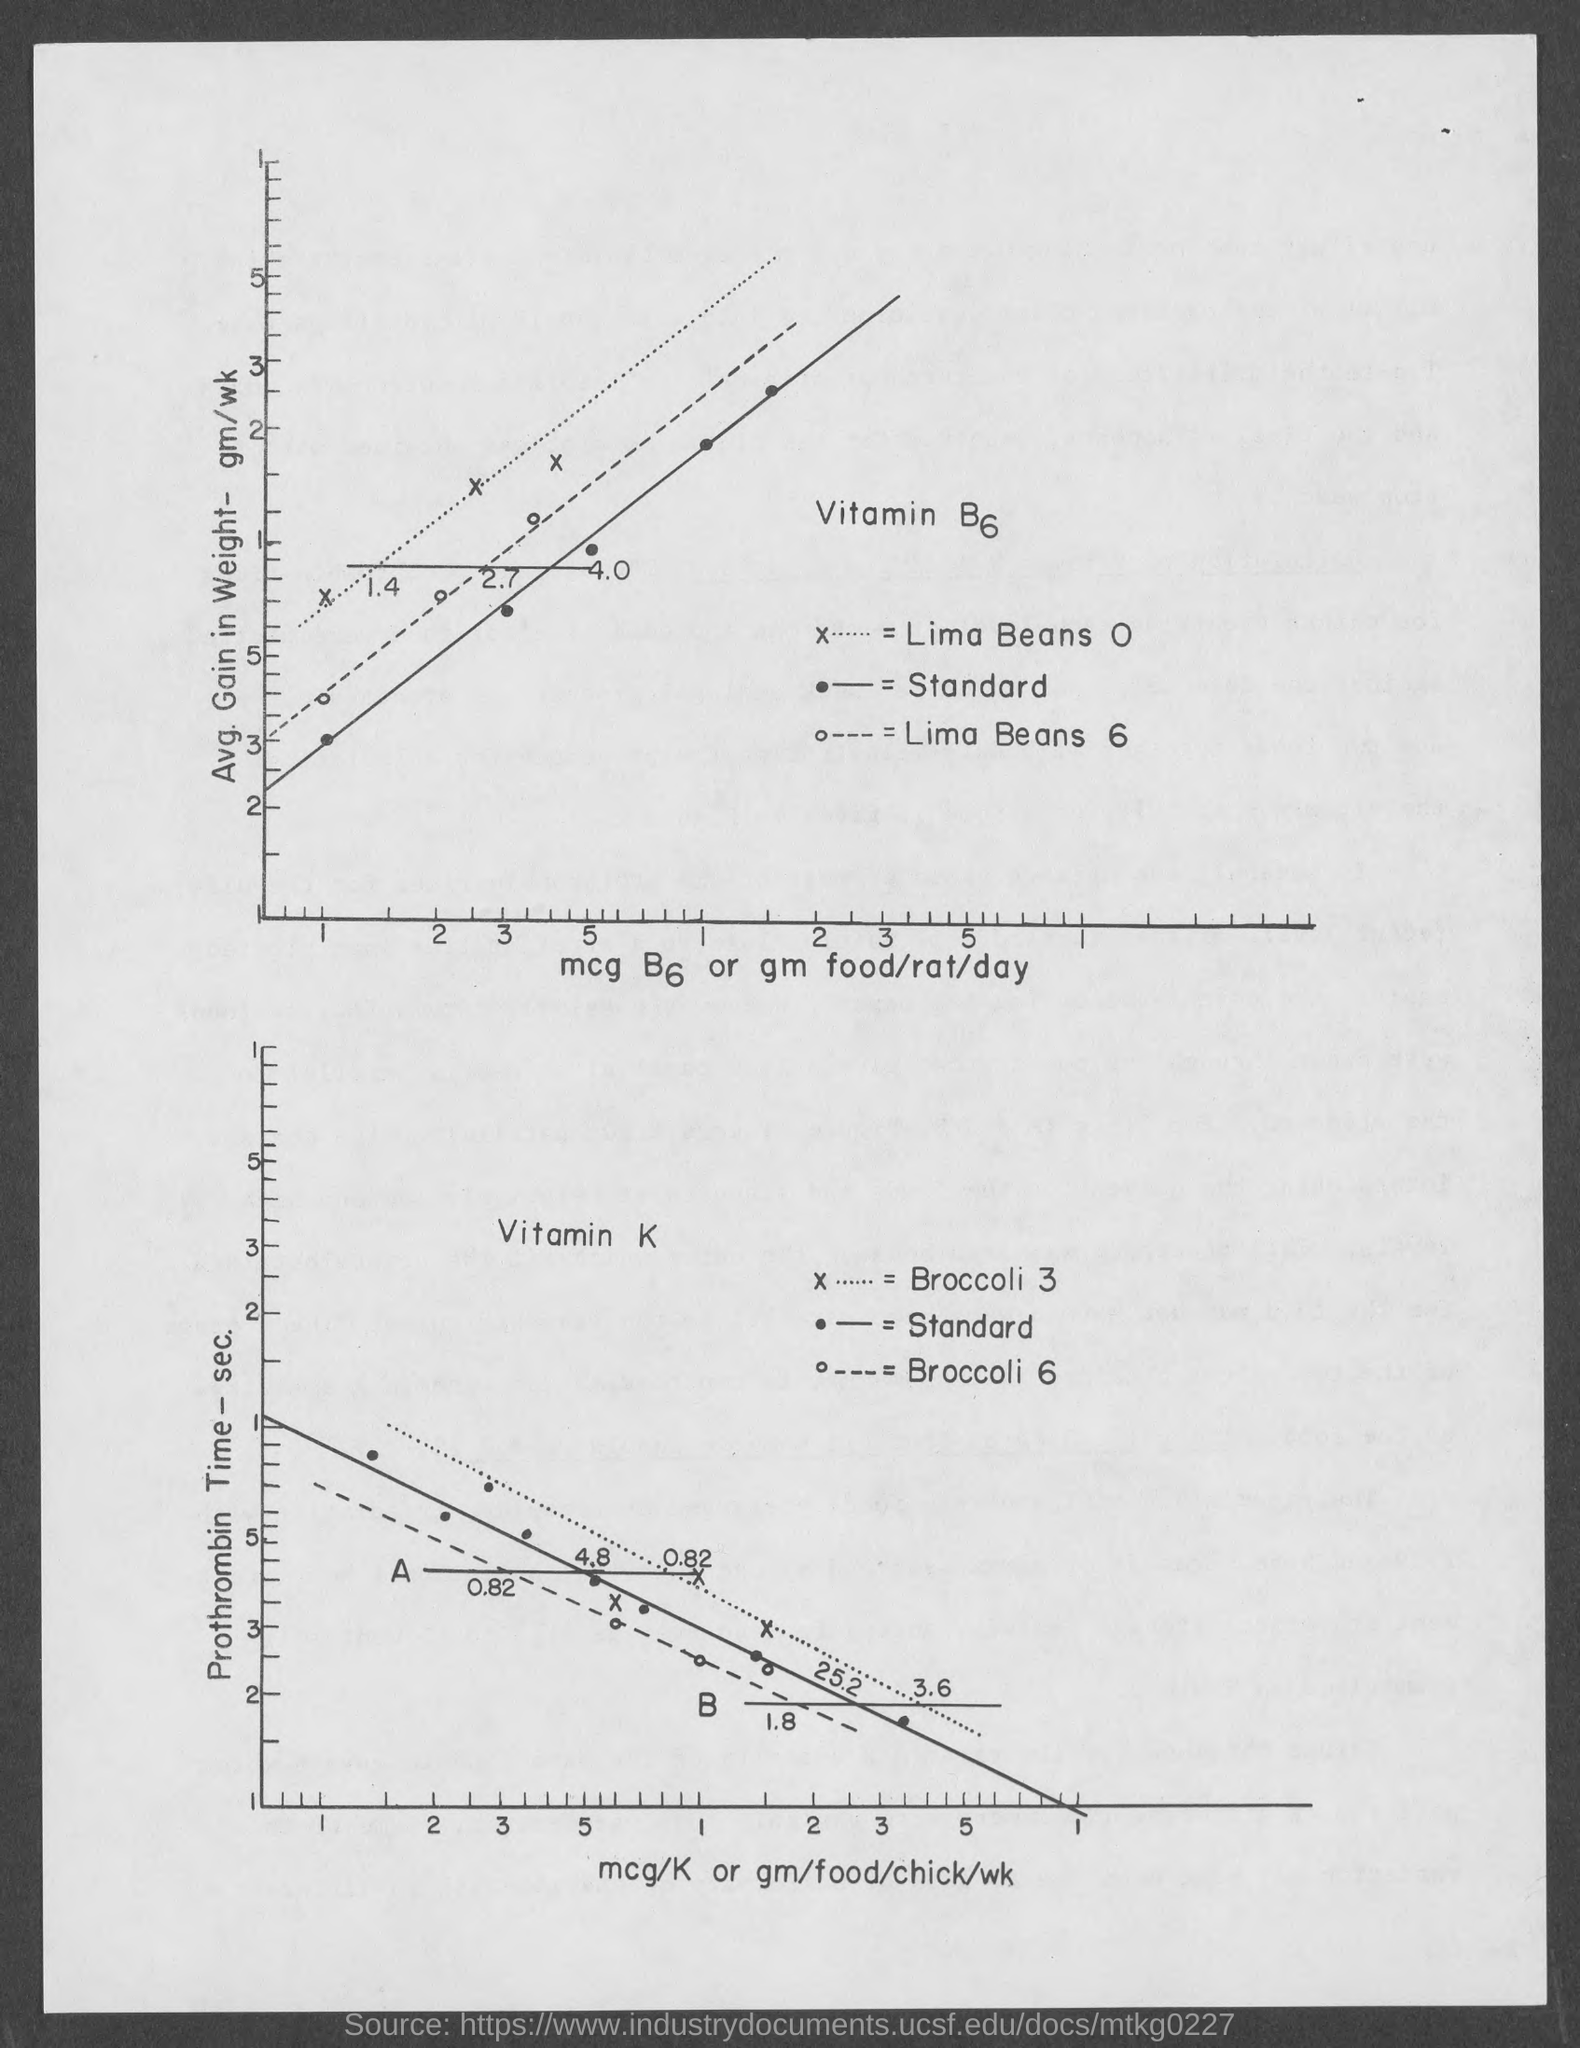Identify some key points in this picture. The average weight gain in grams per week is displayed on the y-axis of the first graph. The unit of measurement on the X axis of the second graph is millicuries per kilogram (mCi/kg), which represents the concentration of radioactive material in units of millicuries per unit of weight. The X axis of the first graph displays units of measurement such as milligrams of B6 (mcg) or grams of food consumed per rat per day. The second graph shows the relationship between the prothrombin time and the concentration of prothrombin in the blood. The prothrombin time is shown on the y-axis of the graph, while the concentration of prothrombin is shown on the x-axis. 